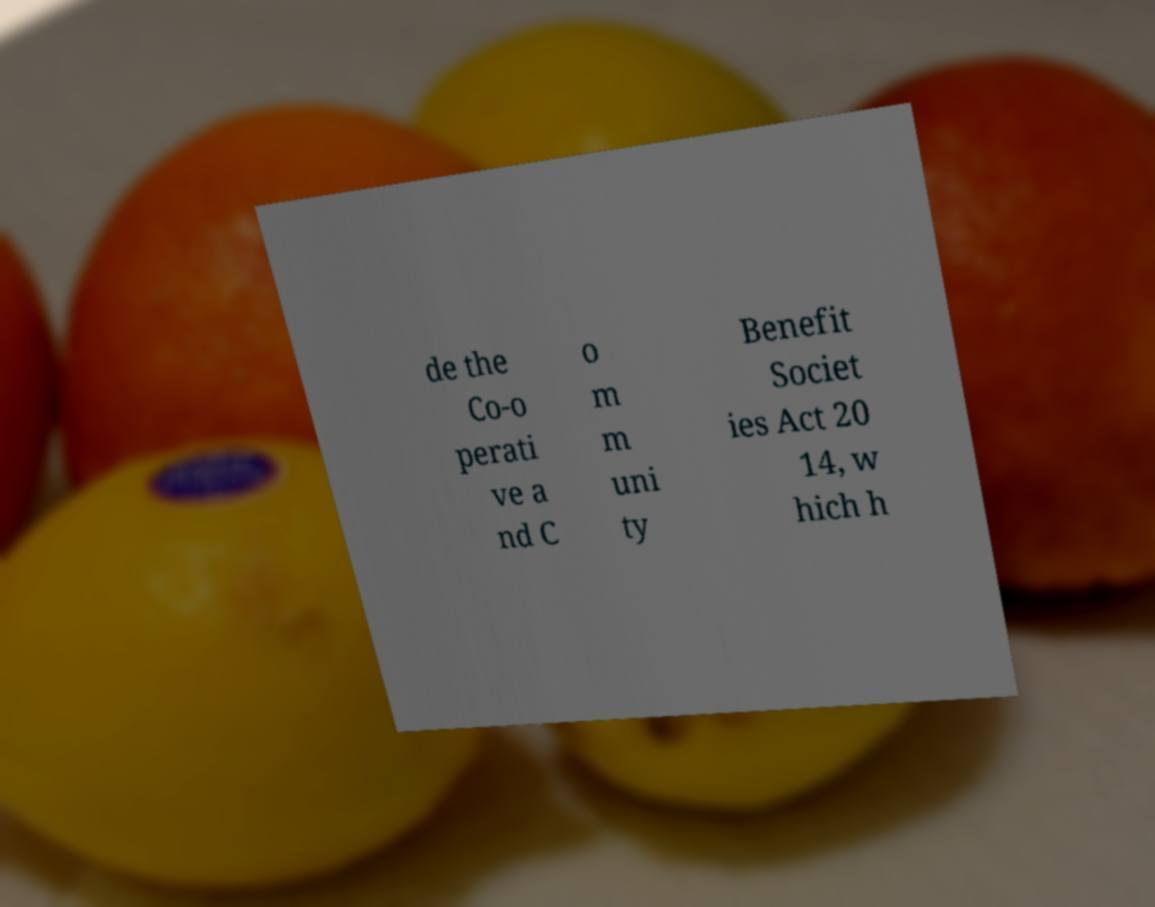I need the written content from this picture converted into text. Can you do that? de the Co-o perati ve a nd C o m m uni ty Benefit Societ ies Act 20 14, w hich h 